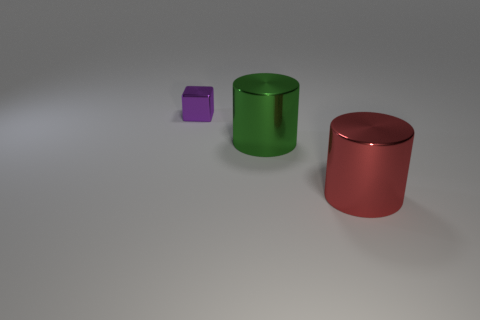Subtract all cyan cylinders. Subtract all yellow balls. How many cylinders are left? 2 Subtract all gray cylinders. How many brown blocks are left? 0 Add 2 large objects. How many small purples exist? 0 Subtract all small cylinders. Subtract all green objects. How many objects are left? 2 Add 1 tiny purple metallic objects. How many tiny purple metallic objects are left? 2 Add 1 shiny cubes. How many shiny cubes exist? 2 Add 3 green cylinders. How many objects exist? 6 Subtract all green cylinders. How many cylinders are left? 1 Subtract 0 gray balls. How many objects are left? 3 Subtract all cylinders. How many objects are left? 1 